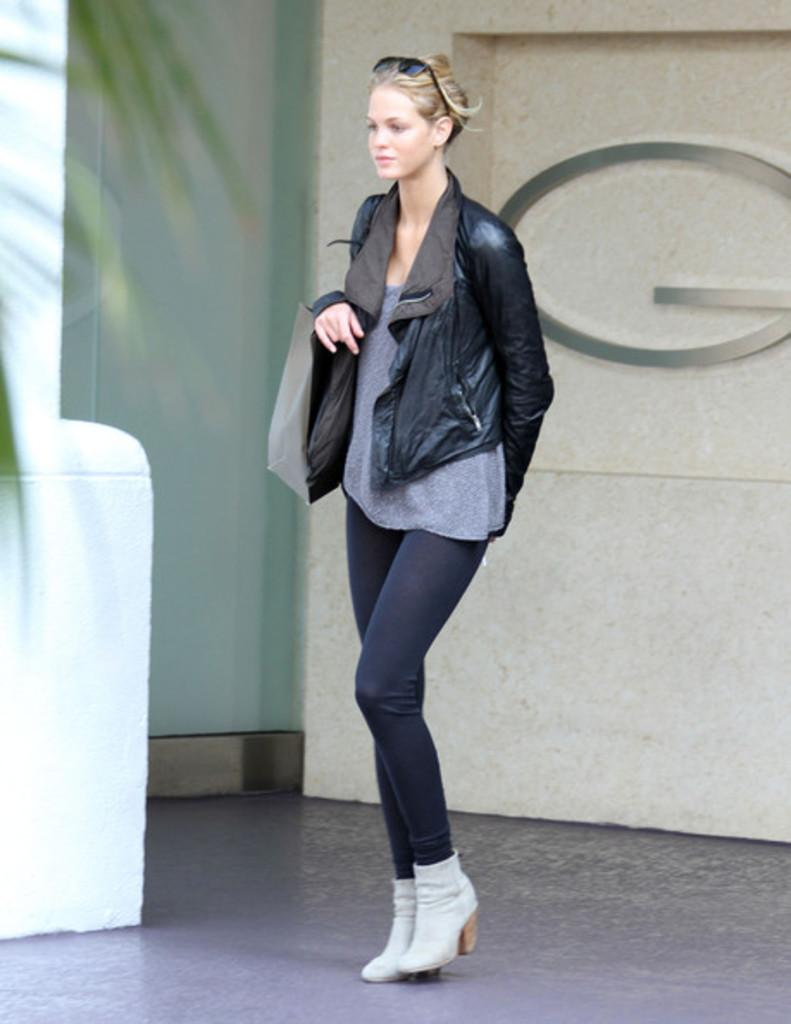What is the main subject of the image? There is a person standing in the image. Where is the person standing? The person is standing on the floor. What can be seen behind the person? There is a wall behind the person. What is in front of the person? There is a tree in front of the person. How many toes can be seen on the person's fingers in the image? There are no toes visible on the person's fingers in the image, as fingers do not have toes. 